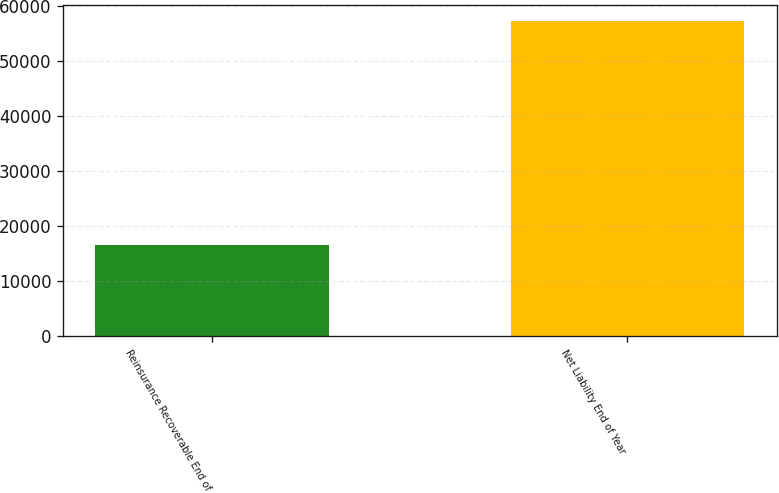Convert chart to OTSL. <chart><loc_0><loc_0><loc_500><loc_500><bar_chart><fcel>Reinsurance Recoverable End of<fcel>Net Liability End of Year<nl><fcel>16472<fcel>57336<nl></chart> 